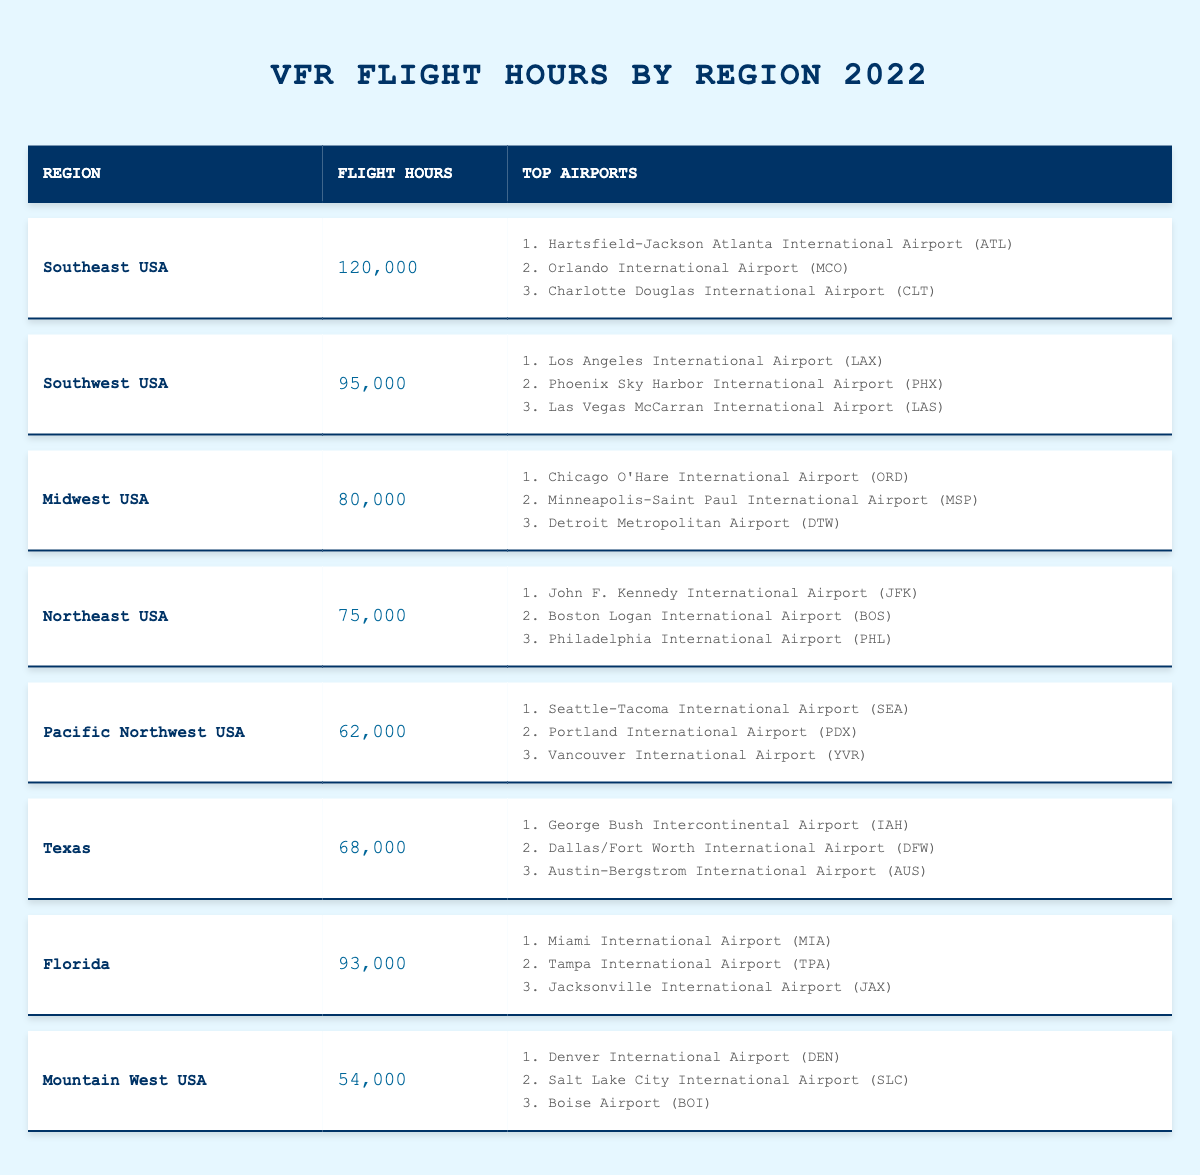What region logged the most flight hours in 2022? Referring to the table, the Southeast USA region has the highest value of 120,000 flight hours.
Answer: Southeast USA How many flight hours did the Florida region log? The Florida region logged 93,000 flight hours, as listed in the table.
Answer: 93,000 Which region has logged the least flight hours in 2022? The Mountain West USA region has the least flight hours with a total of 54,000.
Answer: Mountain West USA What is the total number of flight hours logged by the Northeast and Midwest regions combined? Adding the flight hours of the Northeast (75,000) and Midwest (80,000) gives 75,000 + 80,000 = 155,000.
Answer: 155,000 Did the Southwest USA region log more flight hours than the Texas region? Yes, the Southwest USA region logged 95,000 hours, which is more than Texas's 68,000 hours.
Answer: Yes What are the top three airports in the Southeast USA region? The top three airports listed for the Southeast USA region are Hartsfield-Jackson Atlanta International Airport (ATL), Orlando International Airport (MCO), and Charlotte Douglas International Airport (CLT).
Answer: ATL, MCO, CLT What is the average number of flight hours logged across all regions in 2022? Summing all the flight hours (120,000 + 95,000 + 80,000 + 75,000 + 62,000 + 68,000 + 93,000 + 54,000 =  707,000) and dividing by the number of regions (8) gives an average of 707,000 / 8 = 88,375.
Answer: 88,375 Is the total flight hours of the Pacific Northwest region higher than the Mountain West region? Yes, the Pacific Northwest USA region logged 62,000 hours, which is greater than the Mountain West's 54,000 hours.
Answer: Yes Which region's flight hours are closer to 90,000, the Florida or the Southwest USA region? The Florida region logged 93,000 hours, which is closer to 90,000 than the Southwest USA region which logged 95,000 hours.
Answer: Florida What percentage of total flight hours does the Midwest region account for? The total flight hours are 707,000, and the Midwest region logged 80,000 hours. Calculating the percentage gives (80,000 / 707,000)*100 ≈ 11.31%.
Answer: 11.31% 